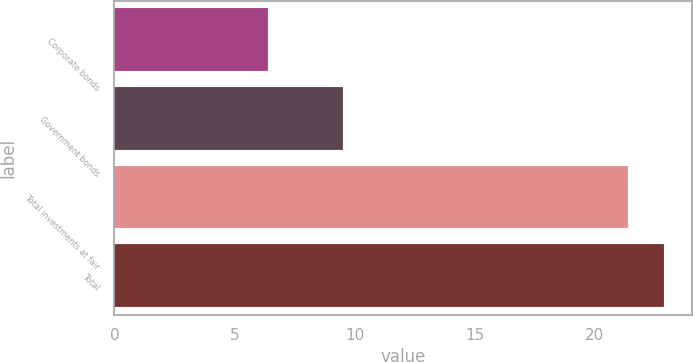<chart> <loc_0><loc_0><loc_500><loc_500><bar_chart><fcel>Corporate bonds<fcel>Government bonds<fcel>Total investments at fair<fcel>Total<nl><fcel>6.4<fcel>9.5<fcel>21.4<fcel>22.9<nl></chart> 